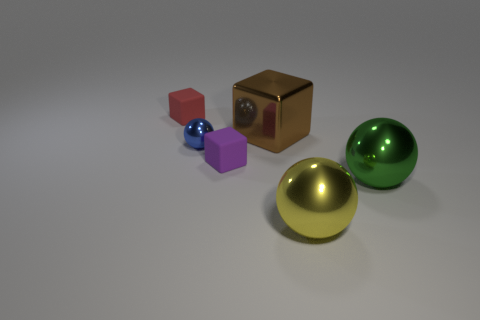If this image was used as a visual teaching aid, what concepts could it help illustrate? This image could serve as an excellent tool for teaching a variety of concepts. For one, it illustrates basic geometric shapes and colors for a young audience learning about these basics. Then there's the more advanced topic of light and shadow, which can help in discussions about how light behaves and the properties of different materials. Additionally, the image could contribute to a lesson on three-dimensional rendering, demonstrating how virtual objects can be created and manipulated to mimic real-life physics and lighting. 